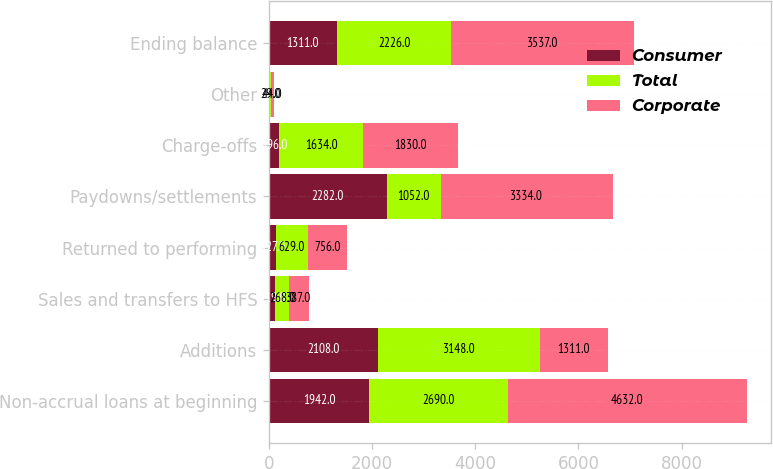Convert chart to OTSL. <chart><loc_0><loc_0><loc_500><loc_500><stacked_bar_chart><ecel><fcel>Non-accrual loans at beginning<fcel>Additions<fcel>Sales and transfers to HFS<fcel>Returned to performing<fcel>Paydowns/settlements<fcel>Charge-offs<fcel>Other<fcel>Ending balance<nl><fcel>Consumer<fcel>1942<fcel>2108<fcel>119<fcel>127<fcel>2282<fcel>196<fcel>15<fcel>1311<nl><fcel>Total<fcel>2690<fcel>3148<fcel>268<fcel>629<fcel>1052<fcel>1634<fcel>29<fcel>2226<nl><fcel>Corporate<fcel>4632<fcel>1311<fcel>387<fcel>756<fcel>3334<fcel>1830<fcel>44<fcel>3537<nl></chart> 